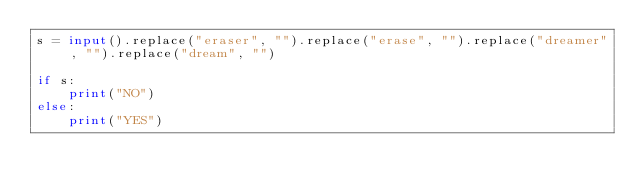Convert code to text. <code><loc_0><loc_0><loc_500><loc_500><_Python_>s = input().replace("eraser", "").replace("erase", "").replace("dreamer", "").replace("dream", "")

if s:
    print("NO")
else:
    print("YES")</code> 